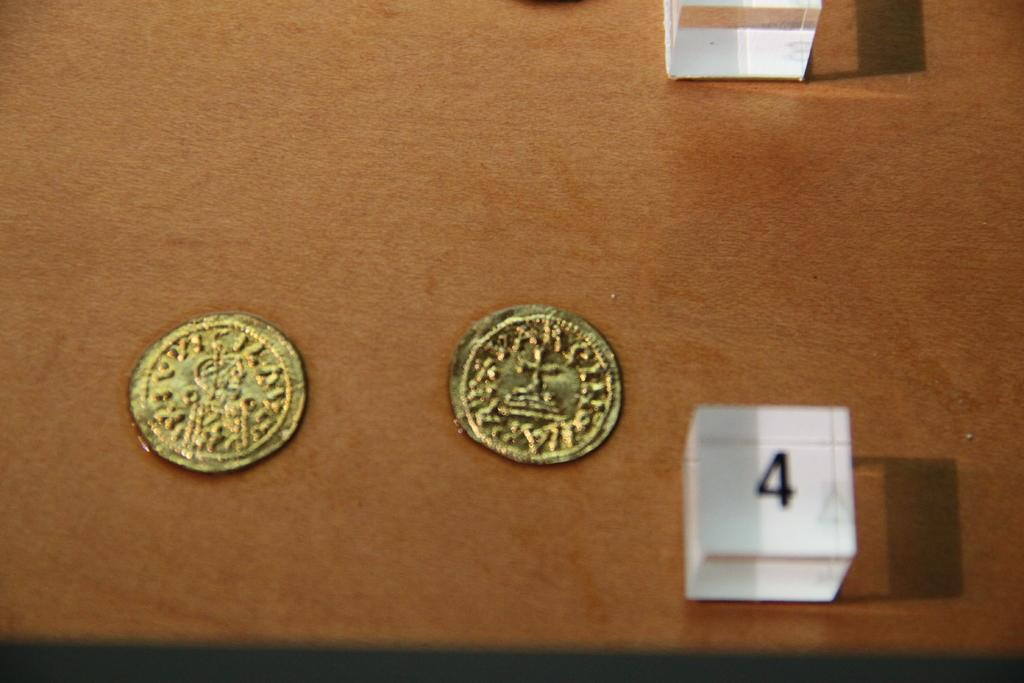<image>
Render a clear and concise summary of the photo. two old gold coins on a wooden table with a number four in a cube 